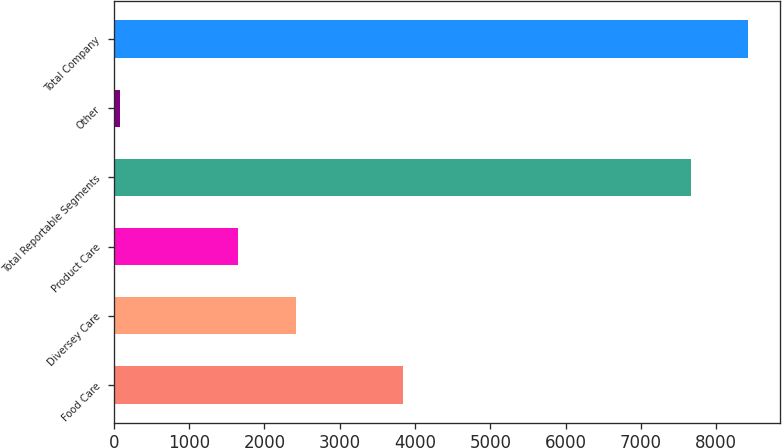Convert chart to OTSL. <chart><loc_0><loc_0><loc_500><loc_500><bar_chart><fcel>Food Care<fcel>Diversey Care<fcel>Product Care<fcel>Total Reportable Segments<fcel>Other<fcel>Total Company<nl><fcel>3835.3<fcel>2421.34<fcel>1655<fcel>7663.4<fcel>87.1<fcel>8429.74<nl></chart> 